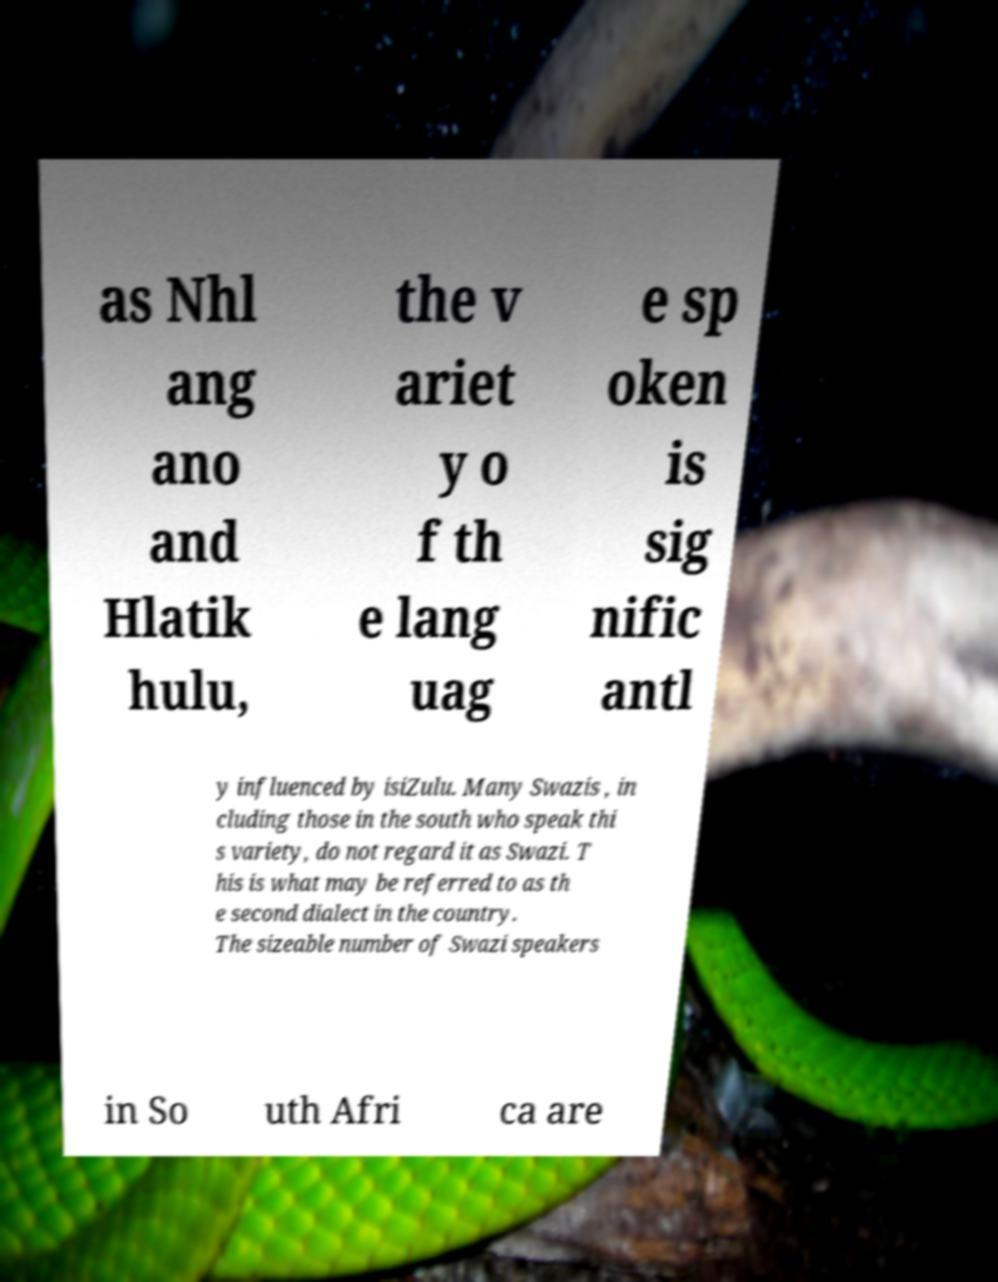Please read and relay the text visible in this image. What does it say? as Nhl ang ano and Hlatik hulu, the v ariet y o f th e lang uag e sp oken is sig nific antl y influenced by isiZulu. Many Swazis , in cluding those in the south who speak thi s variety, do not regard it as Swazi. T his is what may be referred to as th e second dialect in the country. The sizeable number of Swazi speakers in So uth Afri ca are 